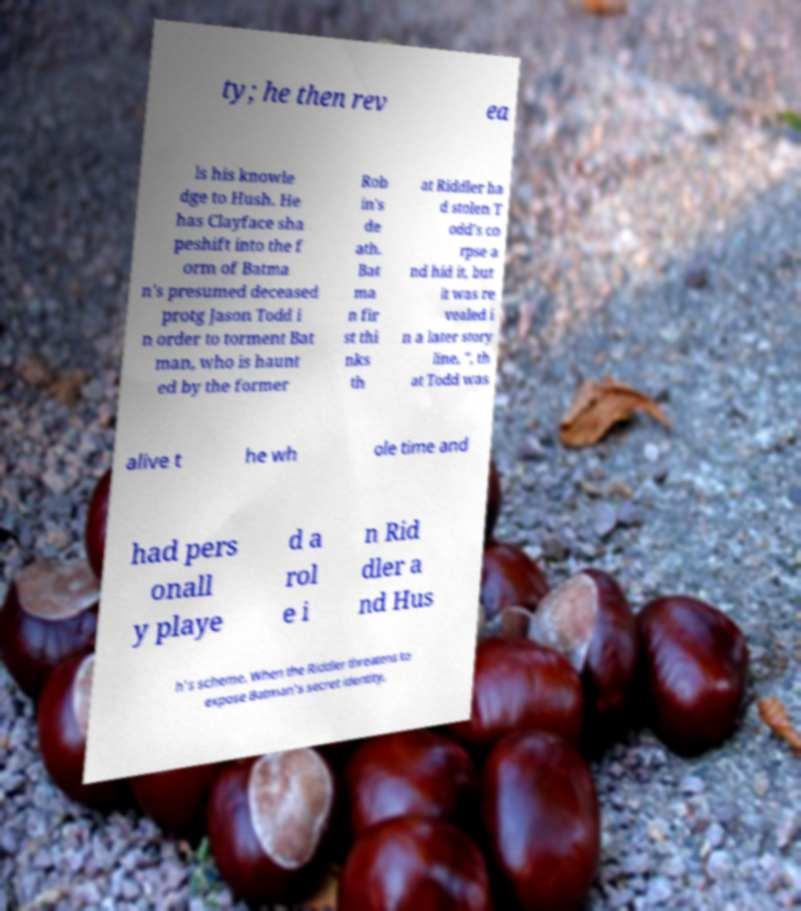Please read and relay the text visible in this image. What does it say? ty; he then rev ea ls his knowle dge to Hush. He has Clayface sha peshift into the f orm of Batma n's presumed deceased protg Jason Todd i n order to torment Bat man, who is haunt ed by the former Rob in's de ath. Bat ma n fir st thi nks th at Riddler ha d stolen T odd's co rpse a nd hid it, but it was re vealed i n a later story line, ", th at Todd was alive t he wh ole time and had pers onall y playe d a rol e i n Rid dler a nd Hus h's scheme. When the Riddler threatens to expose Batman's secret identity, 